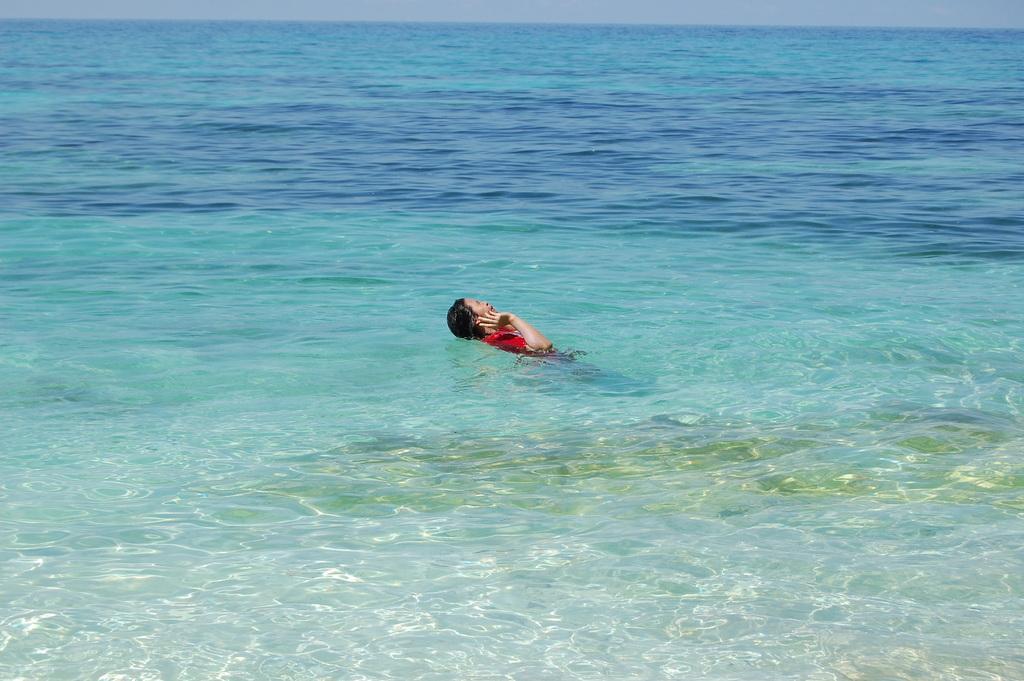Could you give a brief overview of what you see in this image? In this image I can see in the middle there is a person in the water. This person is wearing the red color t-shirt. 